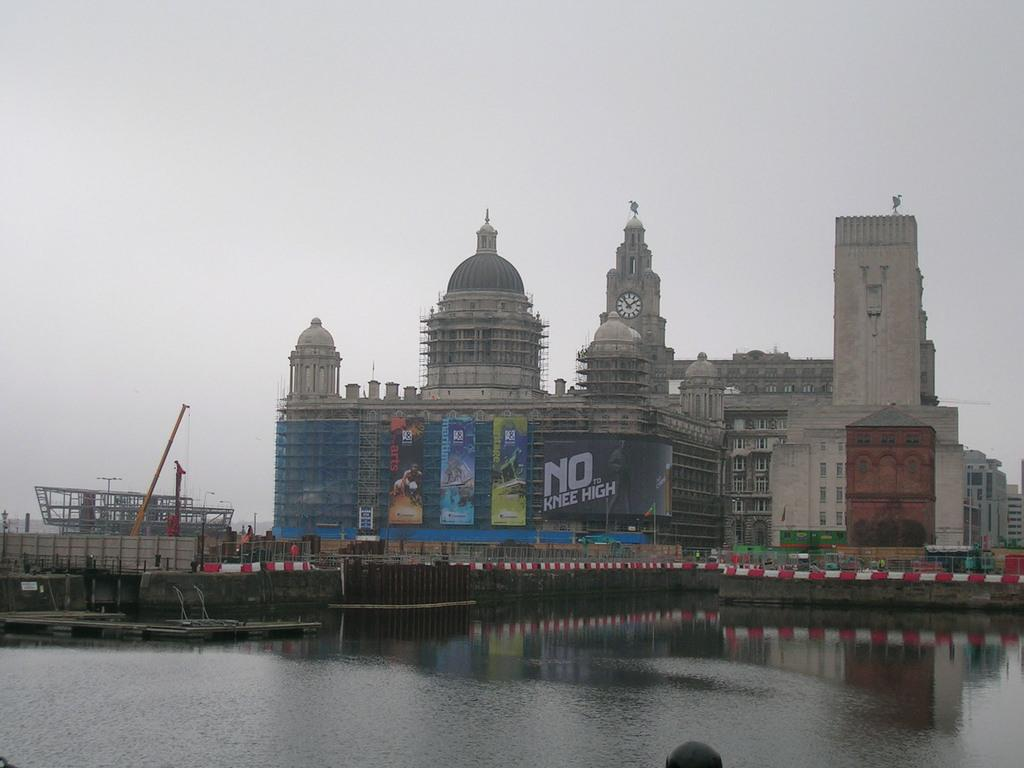What type of structures can be seen in the image? There are buildings in the image. Are there any signs or advertisements visible in the image? Yes, there are hoardings in the image. What is a prominent feature in the image? There is a clock tower in the image. What type of machinery can be seen on the left side of the image? There are cranes on the left side of the image. What natural element is visible in the image? There is water visible in the image. What can be seen in the background of the image? The sky is visible in the background of the image. What type of camera is being used to take the picture of the steel in the image? There is no camera or steel present in the image; it features buildings, hoardings, a clock tower, cranes, water, and the sky. Can you tell me how many airplanes are flying in the image? There are no airplanes visible in the image. 